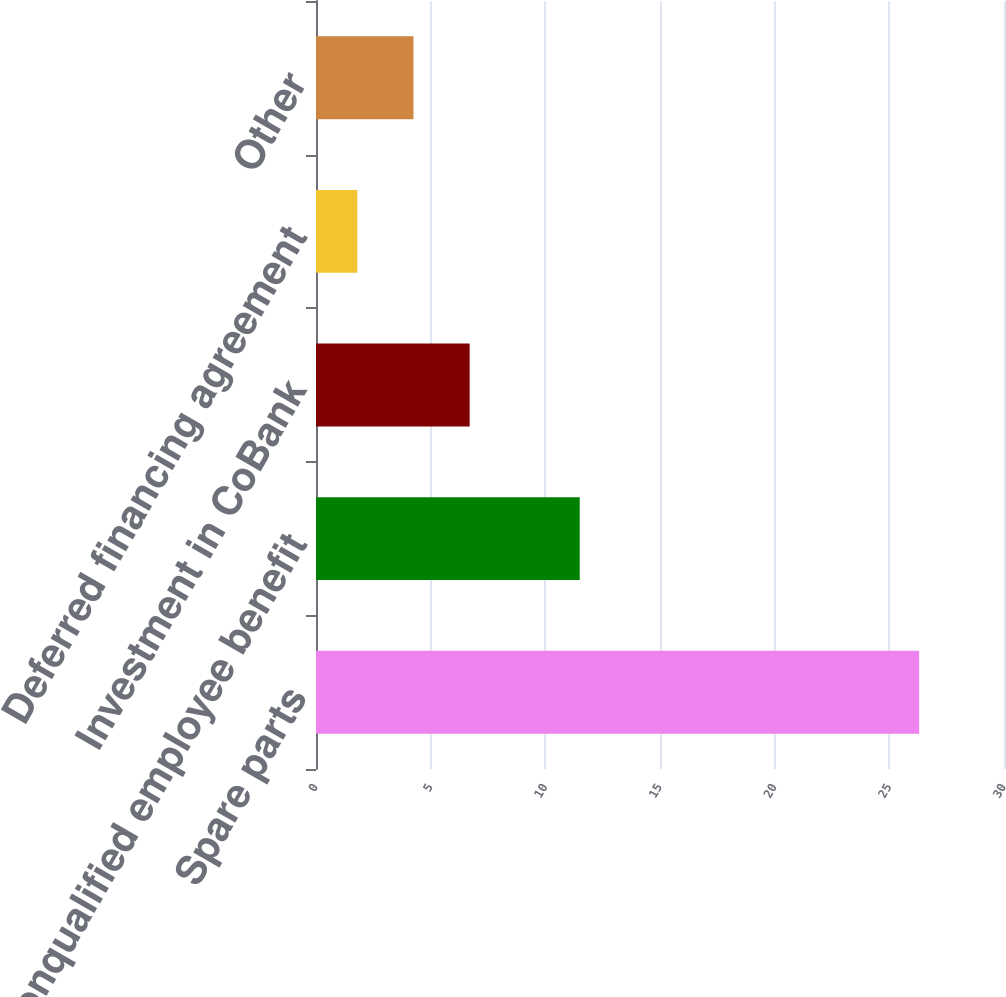Convert chart. <chart><loc_0><loc_0><loc_500><loc_500><bar_chart><fcel>Spare parts<fcel>Nonqualified employee benefit<fcel>Investment in CoBank<fcel>Deferred financing agreement<fcel>Other<nl><fcel>26.3<fcel>11.5<fcel>6.7<fcel>1.8<fcel>4.25<nl></chart> 